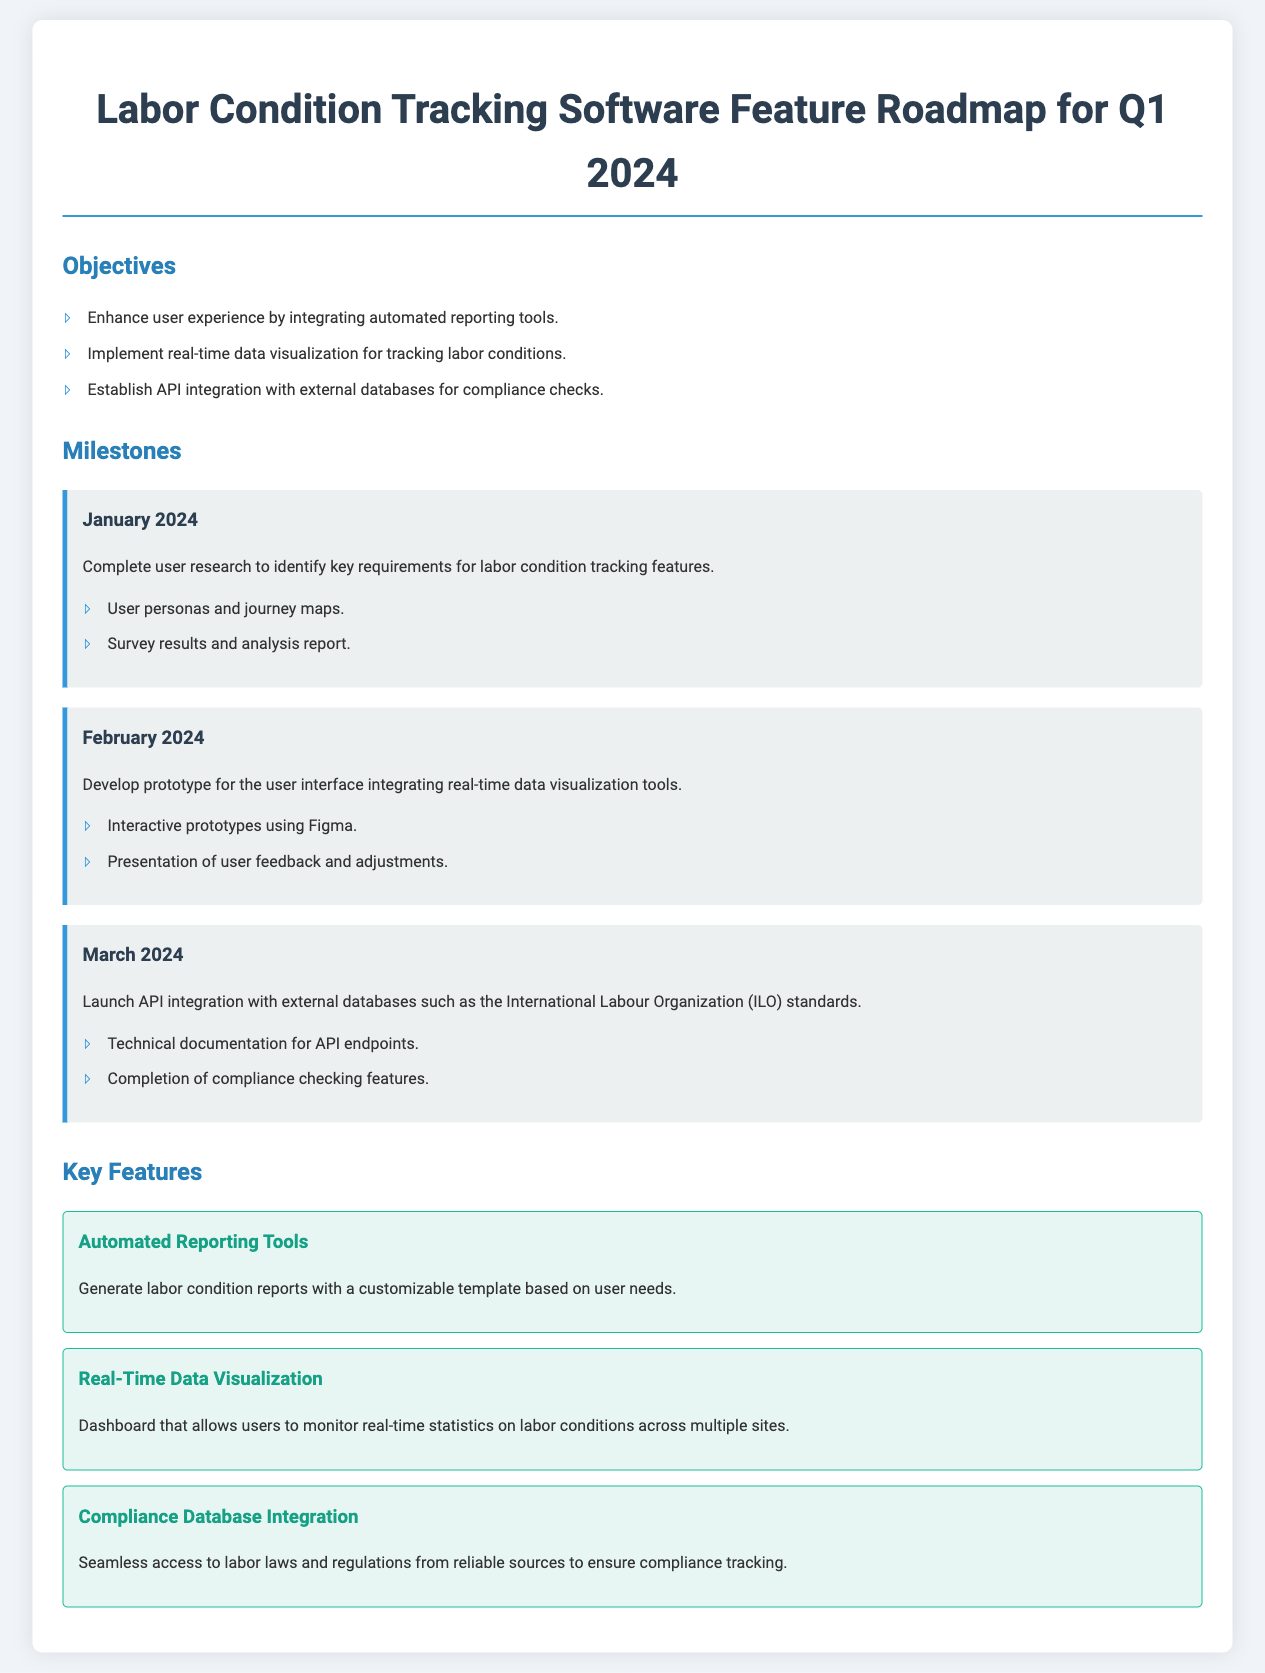What are the key objectives for Q1 2024? The objectives listed in the document outline the main focuses and goals for the first quarter, which includes enhancing user experience, implementing real-time data visualization, and establishing API integration.
Answer: Enhance user experience by integrating automated reporting tools, Implement real-time data visualization for tracking labor conditions, Establish API integration with external databases for compliance checks When is the API integration scheduled to launch? The document provides a timeline for milestones and specifies the month for key developments, including the API integration launch.
Answer: March 2024 What user feedback strategy is mentioned for February 2024? The February milestone highlights the importance of gathering user feedback for refinements after presenting the prototype. This reflects the approach taken towards user-centered design.
Answer: Presentation of user feedback and adjustments Which external databases are targeted for integration according to the roadmap? The roadmap specifies particular institutions or standards relevant to labor laws, focusing on industry-compliance resources.
Answer: International Labour Organization (ILO) What is the feature related to generating reports? The document describes a specific feature that allows users to create reports, emphasizing customization to meet user needs for documentation.
Answer: Automated Reporting Tools How many key features are outlined in the document? The document lists a set of features aimed at improving the software, and counting them reveals the breadth of capabilities being developed.
Answer: Three What type of tool will be integrated to visualize data in real-time? The roadmap discusses specific types of tools that serve to allow users to monitor and interpret data regarding labor conditions effectively.
Answer: Real-Time Data Visualization What is the purpose of the compliance database integration feature? The document provides insight into the intent behind integrating compliance resources to assist users with legal standards.
Answer: Seamless access to labor laws and regulations from reliable sources to ensure compliance tracking 